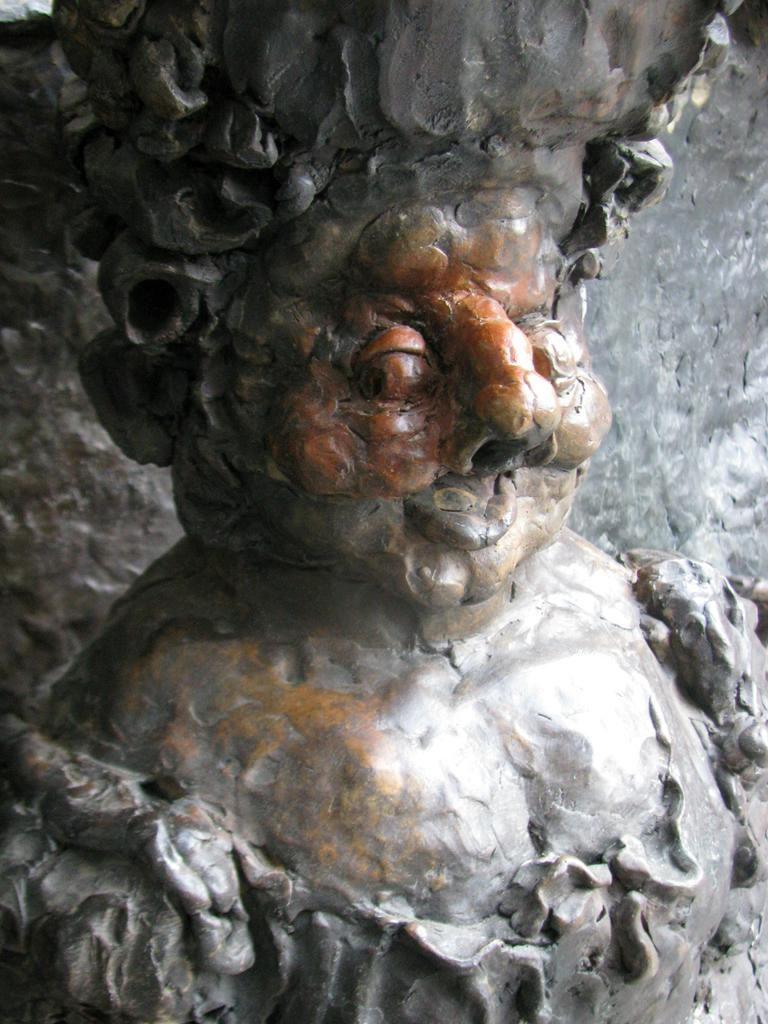What is the main subject of the image? The main subject of the image is a carving. Can you describe the carving in more detail? Unfortunately, the provided facts do not offer any additional details about the carving. What type of net is being used to catch the regret in the image? There is no mention of regret or a net in the image, as the only fact provided is that there is a carving in the image. 